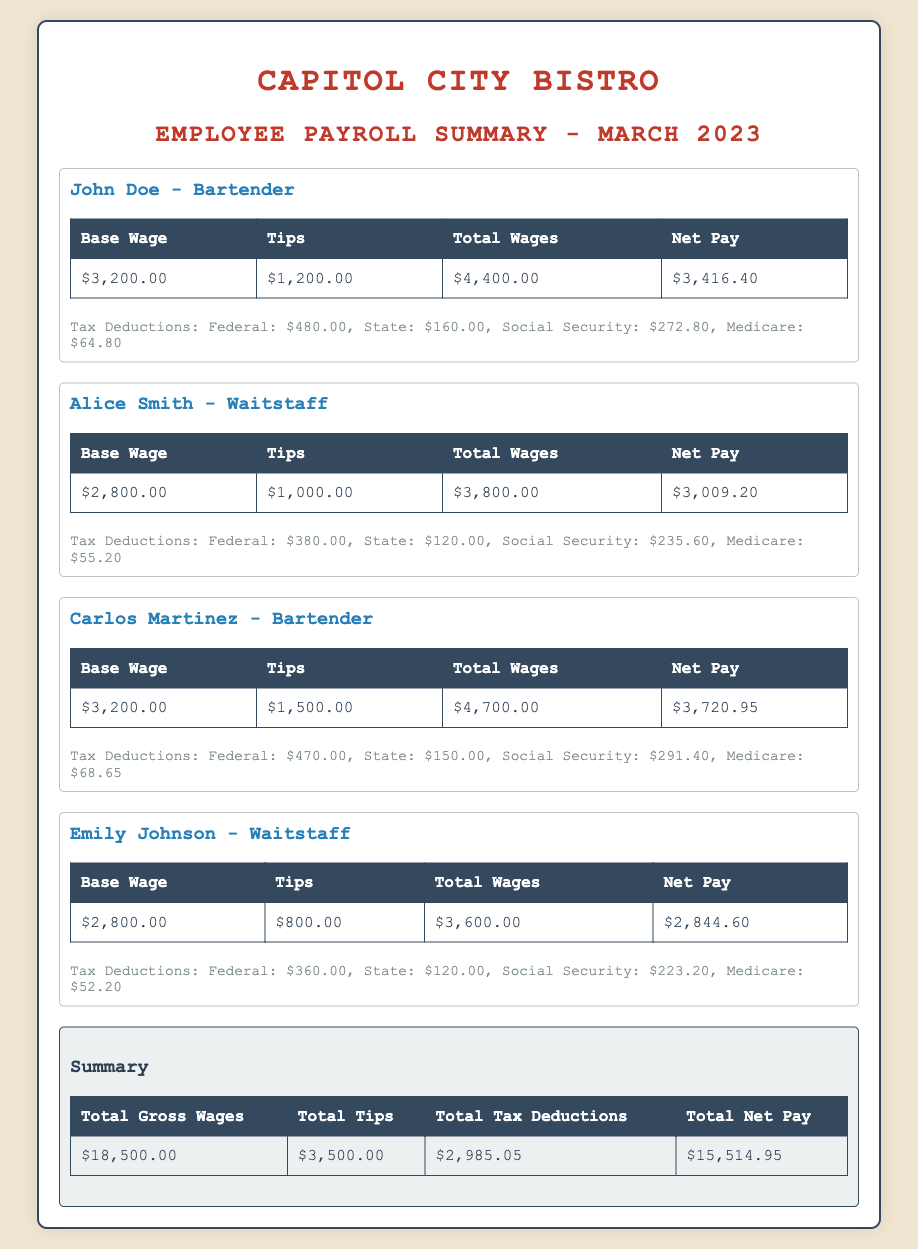What is the total gross wages for March 2023? The total gross wages are listed in the summary section, which states $18,500.00.
Answer: $18,500.00 How much did Carlos Martinez earn in tips? Carlos Martinez's tips are specified in his payment details as $1,500.00.
Answer: $1,500.00 What is the base wage for Alice Smith? Alice Smith's base wage is shown in the document as $2,800.00.
Answer: $2,800.00 What is the total net pay for Emily Johnson? The total net pay for Emily Johnson is mentioned in her section as $2,844.60.
Answer: $2,844.60 How much were the total tax deductions? The total tax deductions can be found in the summary section, noted as $2,985.05.
Answer: $2,985.05 What is the federal tax deduction for John Doe? The federal tax deduction for John Doe is listed as $480.00 in his employee section.
Answer: $480.00 What role does Carlos Martinez hold? Carlos Martinez's job title is indicated clearly in his section as Bartender.
Answer: Bartender How much total tips were distributed among all employees? The total tips distributed are provided in the summary and equal $3,500.00.
Answer: $3,500.00 What does the summary table represent? The summary table provides a consolidated overview of the entire payroll data for March 2023.
Answer: Overview of payroll data 